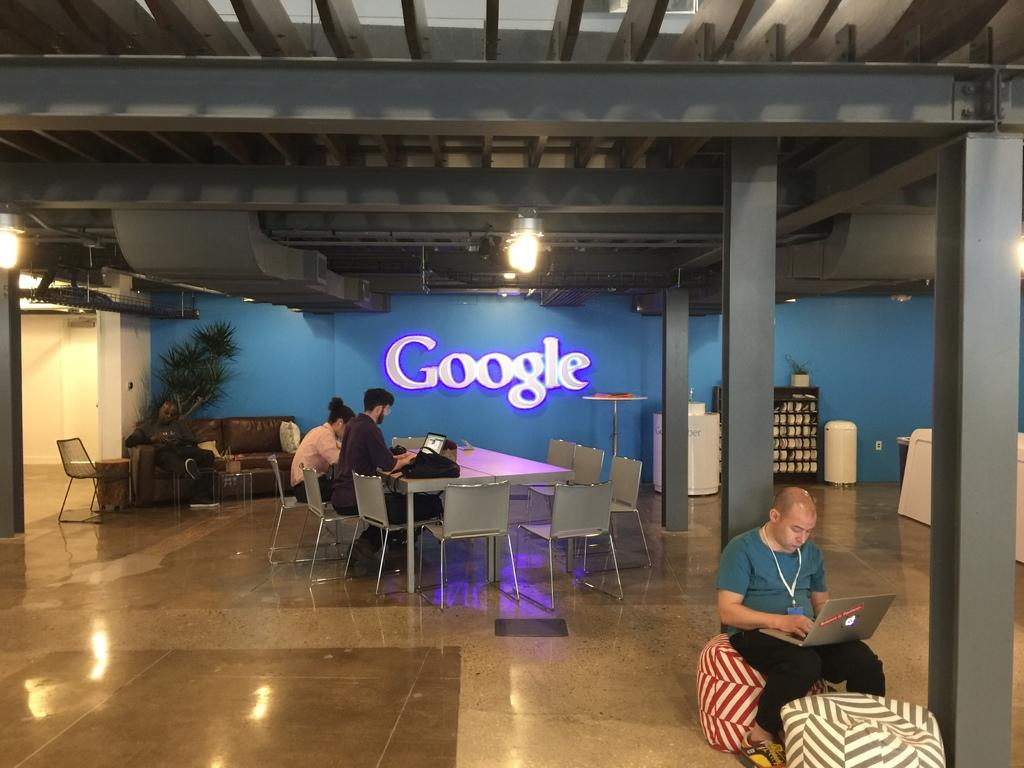How many people are sitting in the image? There are two people sitting on chairs and one person sitting on a sofa. What are the two people on chairs doing? The two people on chairs are working on laptops. What is the person on the sofa doing? The information provided does not specify what the person on the sofa is doing. What can be seen at the top of the image? There is a light visible at the top of the image. What type of payment is being made by the person on the sofa in the image? There is no information about any payment being made in the image. The person on the sofa is not engaged in any activity that suggests a payment is being made. 